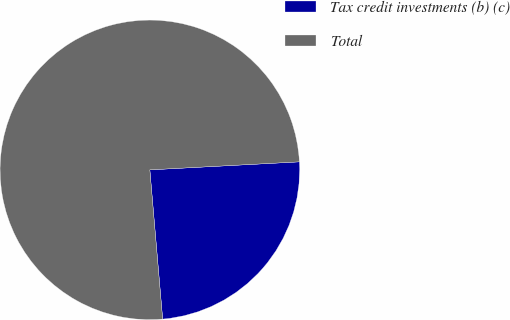Convert chart to OTSL. <chart><loc_0><loc_0><loc_500><loc_500><pie_chart><fcel>Tax credit investments (b) (c)<fcel>Total<nl><fcel>24.49%<fcel>75.51%<nl></chart> 